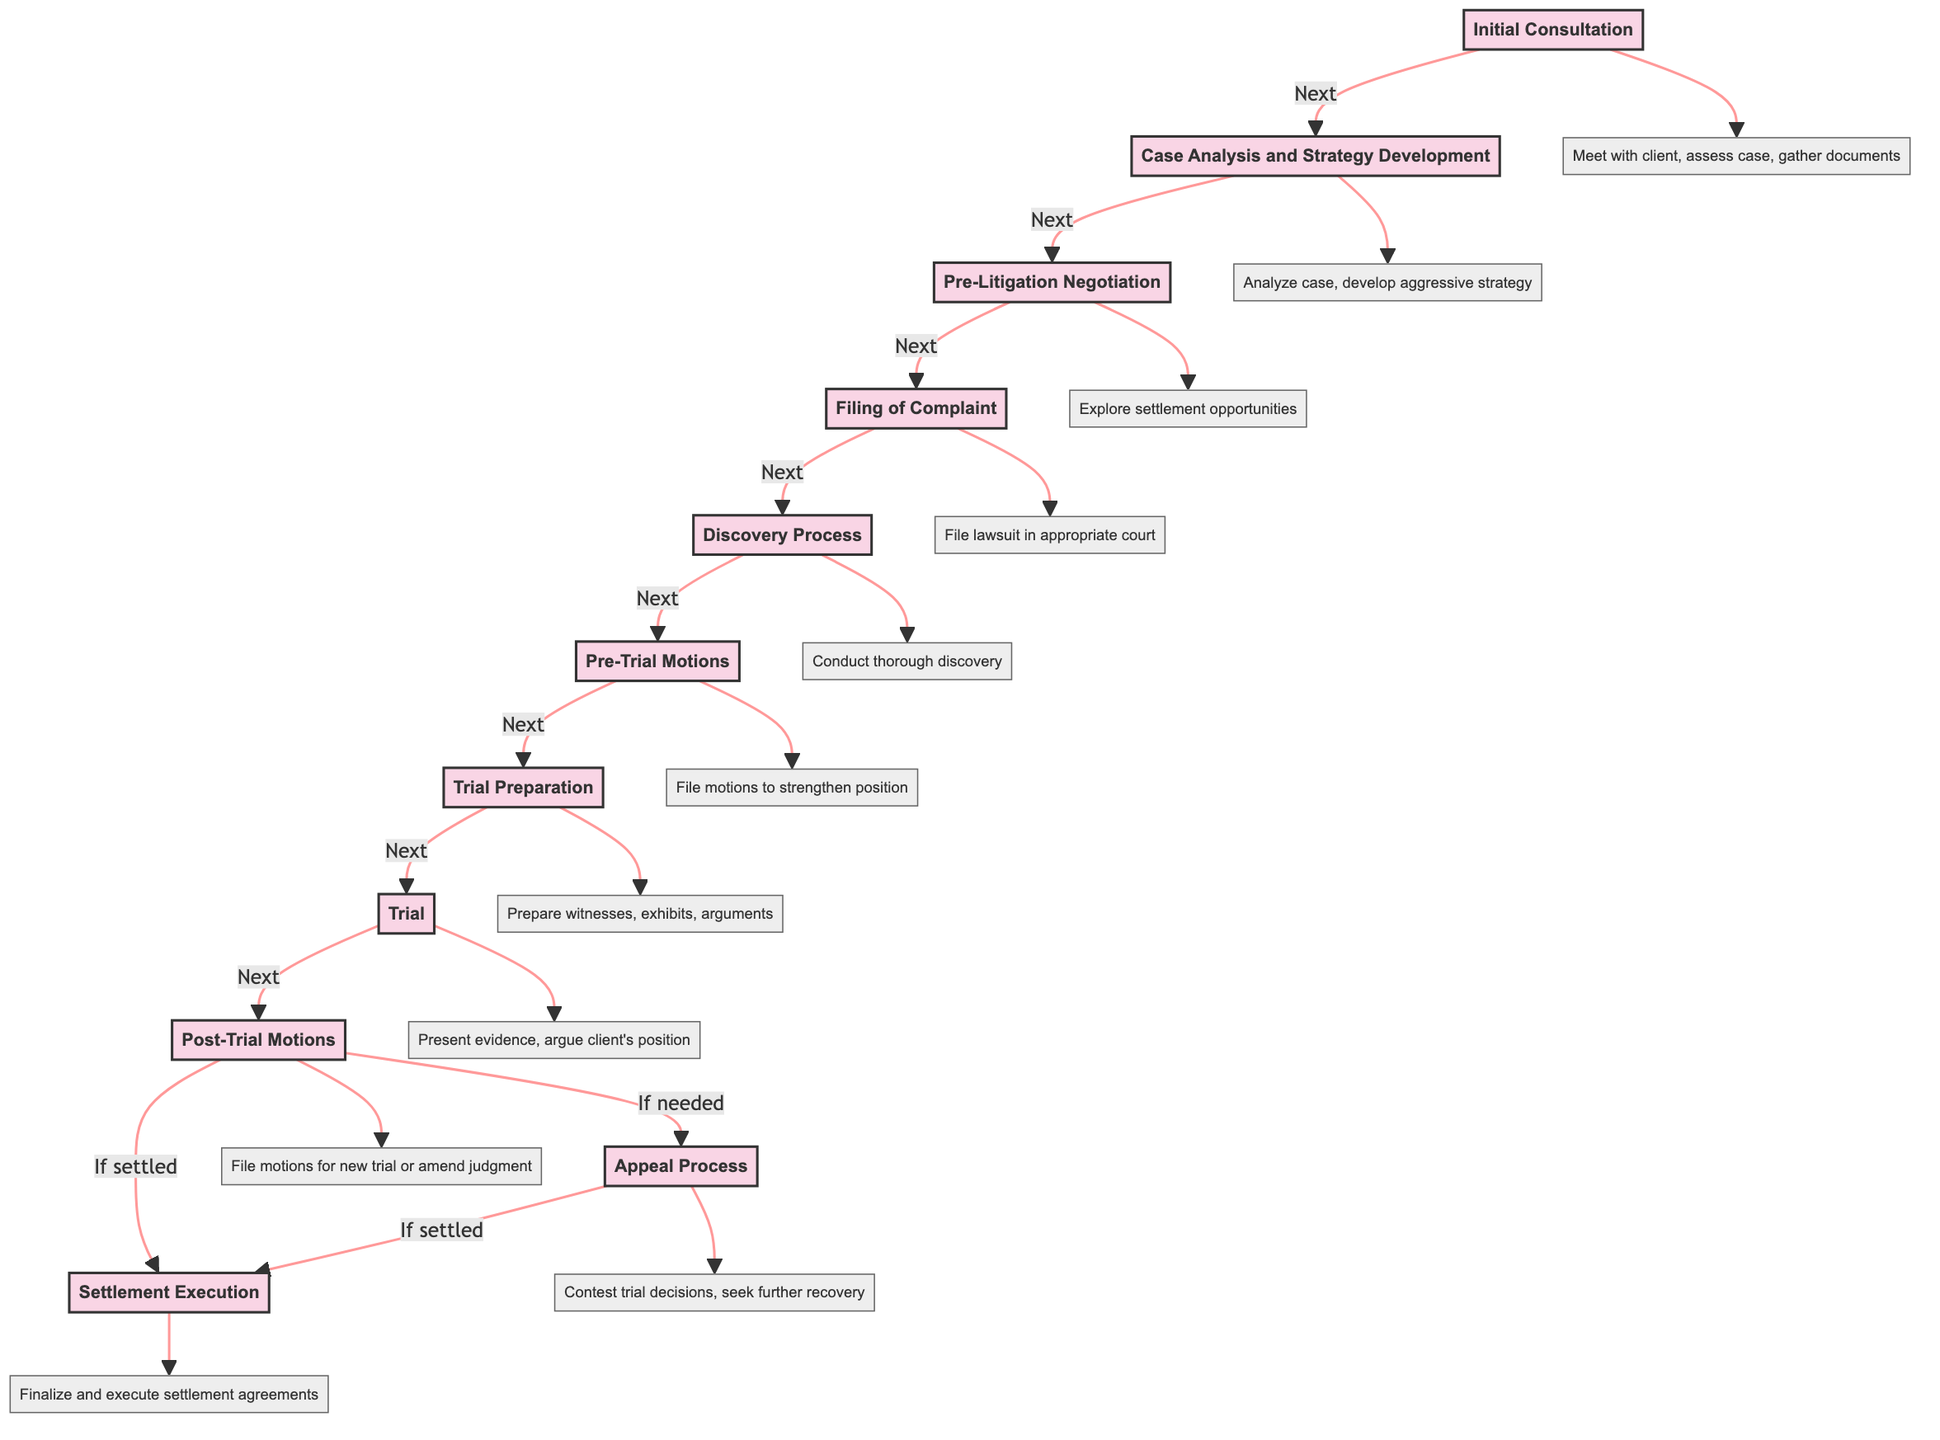What is the first phase in the timeline? The first phase in the timeline is labeled "Initial Consultation," which is the starting point of the multi-phase litigation process.
Answer: Initial Consultation How many phases are there in the timeline? By counting each distinct phase from the diagram, there are a total of 11 phases listed.
Answer: 11 What follows the "Discovery Process"? The diagram indicates that after the "Discovery Process," the next phase is "Pre-Trial Motions."
Answer: Pre-Trial Motions What is the last phase in the timeline? The last phase indicated in the flowchart is "Settlement Execution," which occurs after the potential appeal process if applicable.
Answer: Settlement Execution Which phase involves preparing witnesses? The "Trial Preparation" phase, as described in the diagram, includes the preparation of witnesses, exhibits, and arguments.
Answer: Trial Preparation If post-trial motions are filed, what is the next possible phase? If post-trial motions are needed, the next phase could lead to either the "Appeal Process" or "Settlement Execution" depending on the outcomes.
Answer: Appeal Process or Settlement Execution What does the "Pre-Litigation Negotiation" phase focus on? The focus of the "Pre-Litigation Negotiation" phase is to engage in discussions with opposing parties to explore settlement opportunities before official litigation.
Answer: Settlement opportunities How does the process branch after "Post-Trial Motions"? After "Post-Trial Motions," the process branches into two potential routes: one leading to the "Appeal Process" and the other to "Settlement Execution."
Answer: Two potential routes What does the "Case Analysis and Strategy Development" phase involve? This phase involves analyzing case details and developing an aggressive litigation strategy focused on asset maximization, as indicated in the description.
Answer: Aggressive litigation strategy 